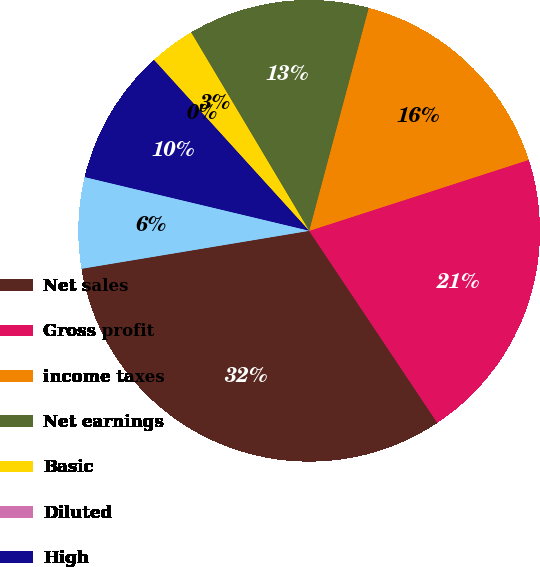Convert chart. <chart><loc_0><loc_0><loc_500><loc_500><pie_chart><fcel>Net sales<fcel>Gross profit<fcel>income taxes<fcel>Net earnings<fcel>Basic<fcel>Diluted<fcel>High<fcel>Low<nl><fcel>31.74%<fcel>20.61%<fcel>15.87%<fcel>12.7%<fcel>3.18%<fcel>0.01%<fcel>9.53%<fcel>6.36%<nl></chart> 